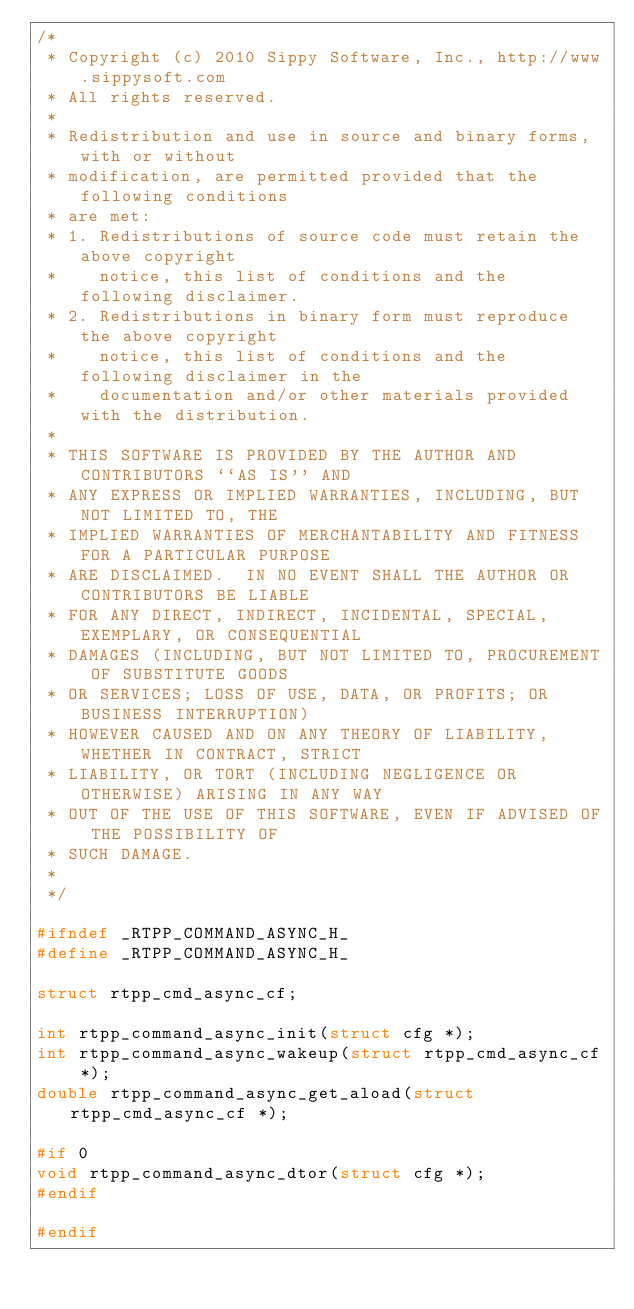<code> <loc_0><loc_0><loc_500><loc_500><_C_>/*
 * Copyright (c) 2010 Sippy Software, Inc., http://www.sippysoft.com
 * All rights reserved.
 *
 * Redistribution and use in source and binary forms, with or without
 * modification, are permitted provided that the following conditions
 * are met:
 * 1. Redistributions of source code must retain the above copyright
 *    notice, this list of conditions and the following disclaimer.
 * 2. Redistributions in binary form must reproduce the above copyright
 *    notice, this list of conditions and the following disclaimer in the
 *    documentation and/or other materials provided with the distribution.
 *
 * THIS SOFTWARE IS PROVIDED BY THE AUTHOR AND CONTRIBUTORS ``AS IS'' AND
 * ANY EXPRESS OR IMPLIED WARRANTIES, INCLUDING, BUT NOT LIMITED TO, THE
 * IMPLIED WARRANTIES OF MERCHANTABILITY AND FITNESS FOR A PARTICULAR PURPOSE
 * ARE DISCLAIMED.  IN NO EVENT SHALL THE AUTHOR OR CONTRIBUTORS BE LIABLE
 * FOR ANY DIRECT, INDIRECT, INCIDENTAL, SPECIAL, EXEMPLARY, OR CONSEQUENTIAL
 * DAMAGES (INCLUDING, BUT NOT LIMITED TO, PROCUREMENT OF SUBSTITUTE GOODS
 * OR SERVICES; LOSS OF USE, DATA, OR PROFITS; OR BUSINESS INTERRUPTION)
 * HOWEVER CAUSED AND ON ANY THEORY OF LIABILITY, WHETHER IN CONTRACT, STRICT
 * LIABILITY, OR TORT (INCLUDING NEGLIGENCE OR OTHERWISE) ARISING IN ANY WAY
 * OUT OF THE USE OF THIS SOFTWARE, EVEN IF ADVISED OF THE POSSIBILITY OF
 * SUCH DAMAGE.
 *
 */

#ifndef _RTPP_COMMAND_ASYNC_H_
#define _RTPP_COMMAND_ASYNC_H_

struct rtpp_cmd_async_cf;

int rtpp_command_async_init(struct cfg *);
int rtpp_command_async_wakeup(struct rtpp_cmd_async_cf *);
double rtpp_command_async_get_aload(struct rtpp_cmd_async_cf *);

#if 0
void rtpp_command_async_dtor(struct cfg *);
#endif

#endif
</code> 